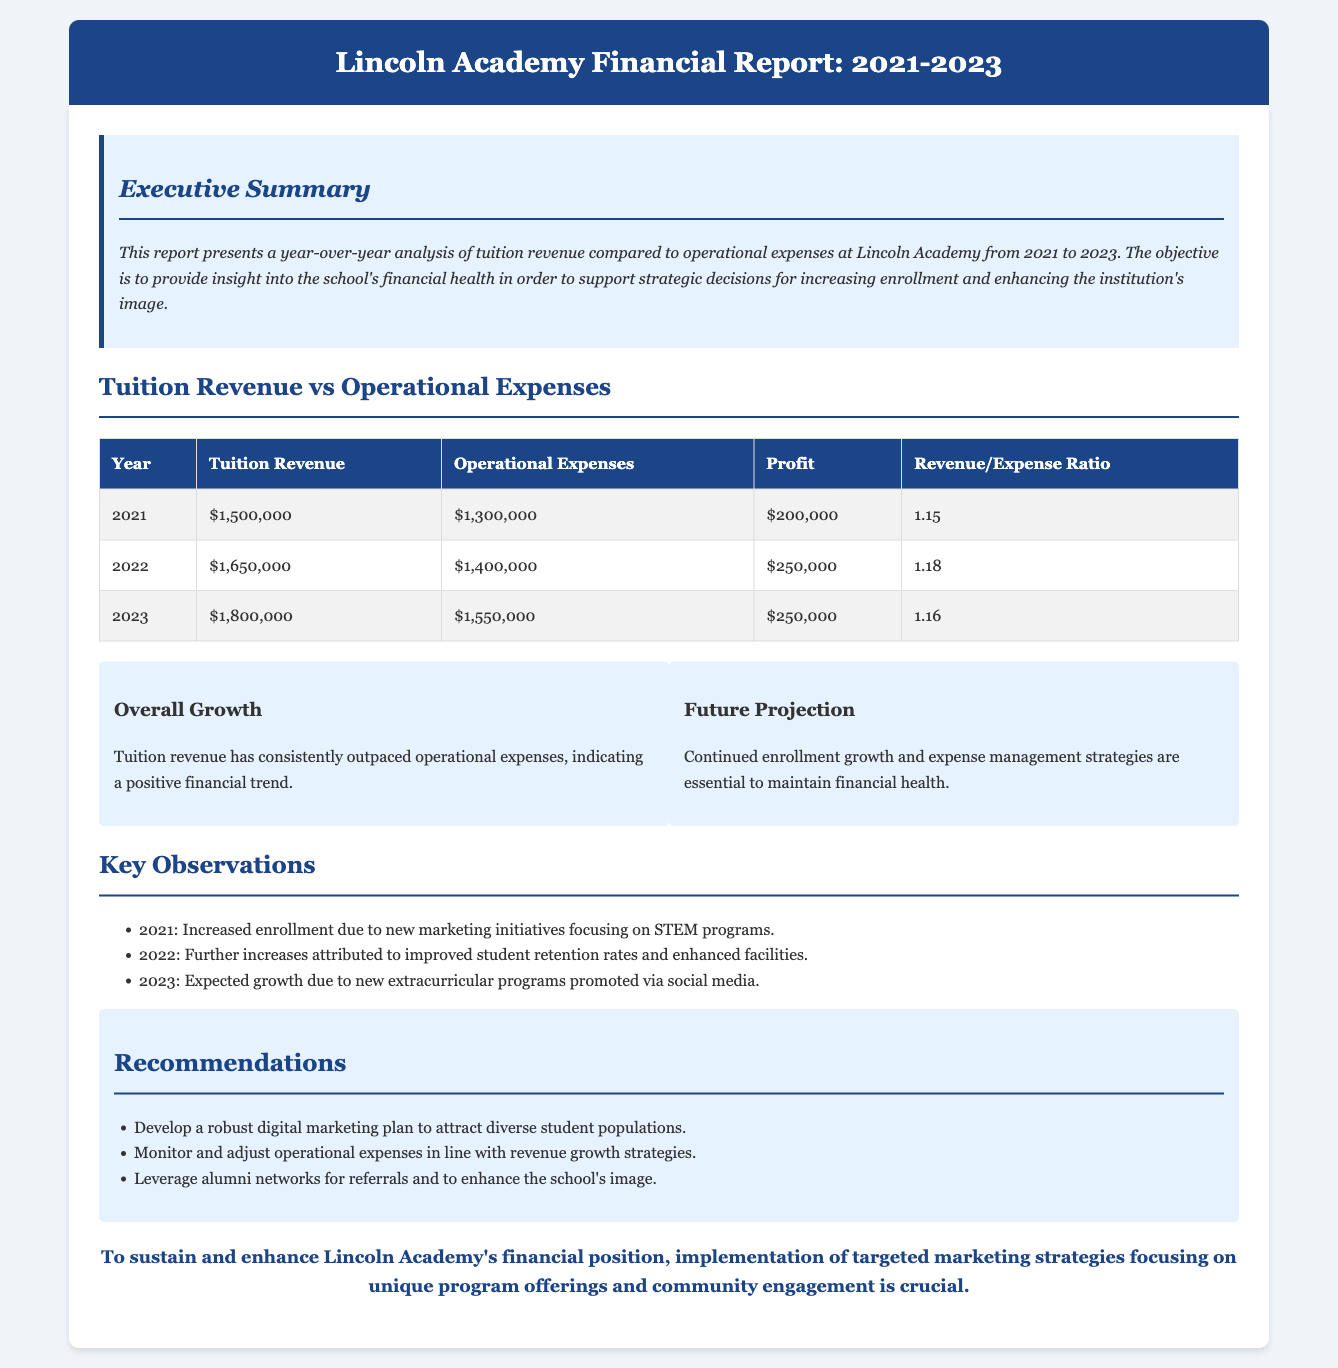What was the tuition revenue in 2021? The document states that the tuition revenue in 2021 was $1,500,000.
Answer: $1,500,000 What were the operational expenses in 2022? The operational expenses for 2022, as shown in the table, were $1,400,000.
Answer: $1,400,000 What was the profit in 2023? According to the report, the profit in 2023 was $250,000.
Answer: $250,000 What is the revenue/expense ratio for 2021? The revenue/expense ratio for 2021 can be found in the table, where it indicates a ratio of 1.15.
Answer: 1.15 Which year had the highest tuition revenue? The year with the highest tuition revenue, as displayed, is 2023 with $1,800,000.
Answer: 2023 What key factors contributed to the enrollment increase in 2021? The report notes that increased enrollment in 2021 was due to new marketing initiatives focusing on STEM programs.
Answer: New marketing initiatives focusing on STEM programs What is a future recommendation for maintaining financial health? One recommendation for maintaining financial health is to monitor and adjust operational expenses in line with revenue growth strategies.
Answer: Monitor and adjust operational expenses How many years does the report cover? The report covers a period of three years: 2021, 2022, and 2023.
Answer: Three years What is the main focus of the executive summary? The executive summary's main focus is to present a year-over-year analysis of tuition revenue compared to operational expenses.
Answer: Year-over-year analysis of tuition revenue compared to operational expenses 